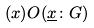<formula> <loc_0><loc_0><loc_500><loc_500>( x ) O ( \underline { x } \colon G )</formula> 